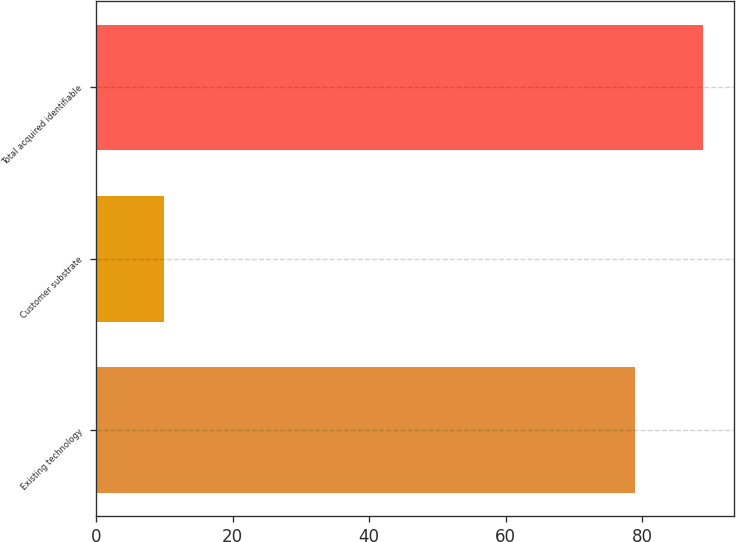Convert chart to OTSL. <chart><loc_0><loc_0><loc_500><loc_500><bar_chart><fcel>Existing technology<fcel>Customer substrate<fcel>Total acquired identifiable<nl><fcel>79<fcel>10<fcel>89<nl></chart> 